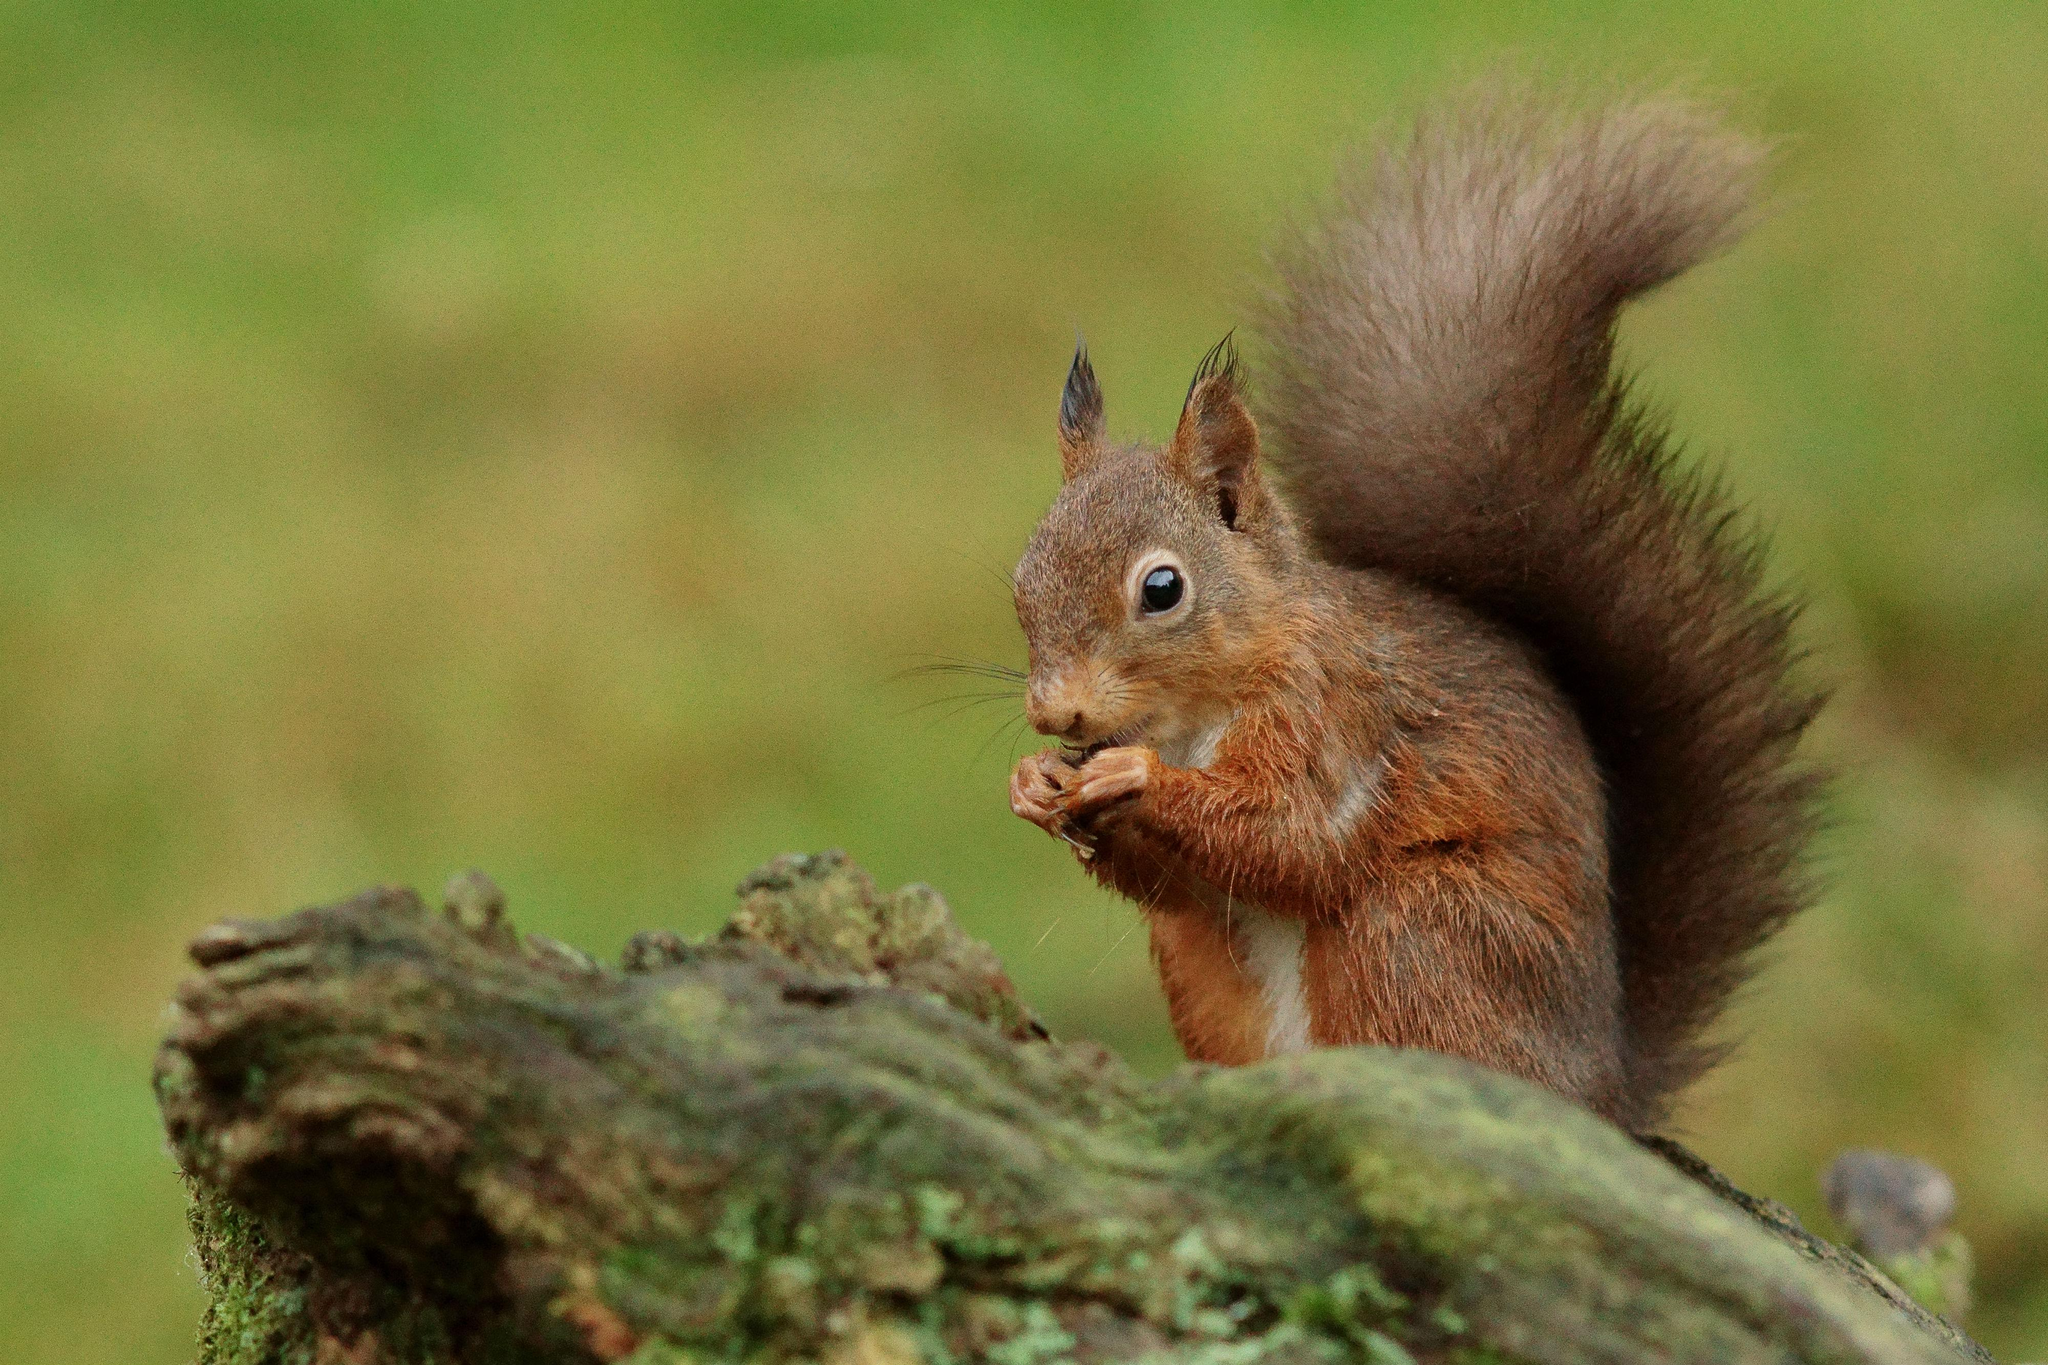What animal can be seen in the image? There is a squirrel in the image. What is the squirrel standing on? The squirrel is standing on a wooden trunk. Can you describe the background of the image? The background of the image is blurry. What type of plant is the stranger holding in the image? There is no stranger present in the image, and therefore no plant can be held by them. 